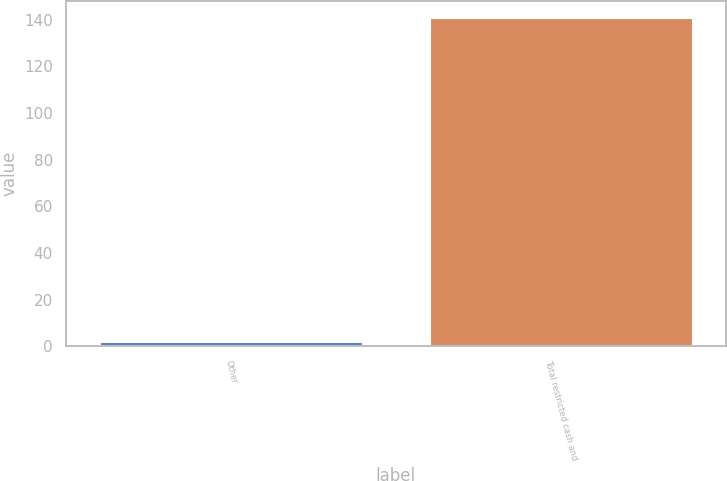<chart> <loc_0><loc_0><loc_500><loc_500><bar_chart><fcel>Other<fcel>Total restricted cash and<nl><fcel>2.5<fcel>141.1<nl></chart> 